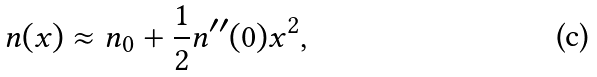Convert formula to latex. <formula><loc_0><loc_0><loc_500><loc_500>n ( x ) \approx n _ { 0 } + \frac { 1 } { 2 } n ^ { \prime \prime } ( 0 ) x ^ { 2 } ,</formula> 